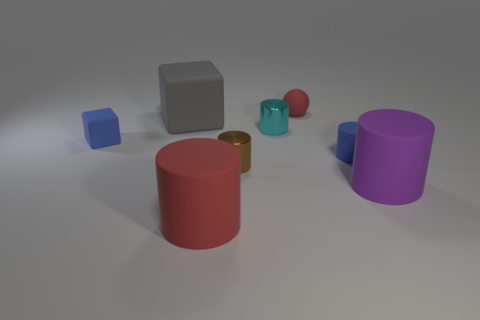Can you describe the composition and layout of the objects in this scene? Certainly! The image shows a variety of geometric shapes, including cylinders, cubes, and spheres, arranged seemingly at random on a flat surface. They vary in size, color, and material, suggesting a diversity that could be used to illustrate concepts of geometry, spatial arrangements, or color differentiation. 